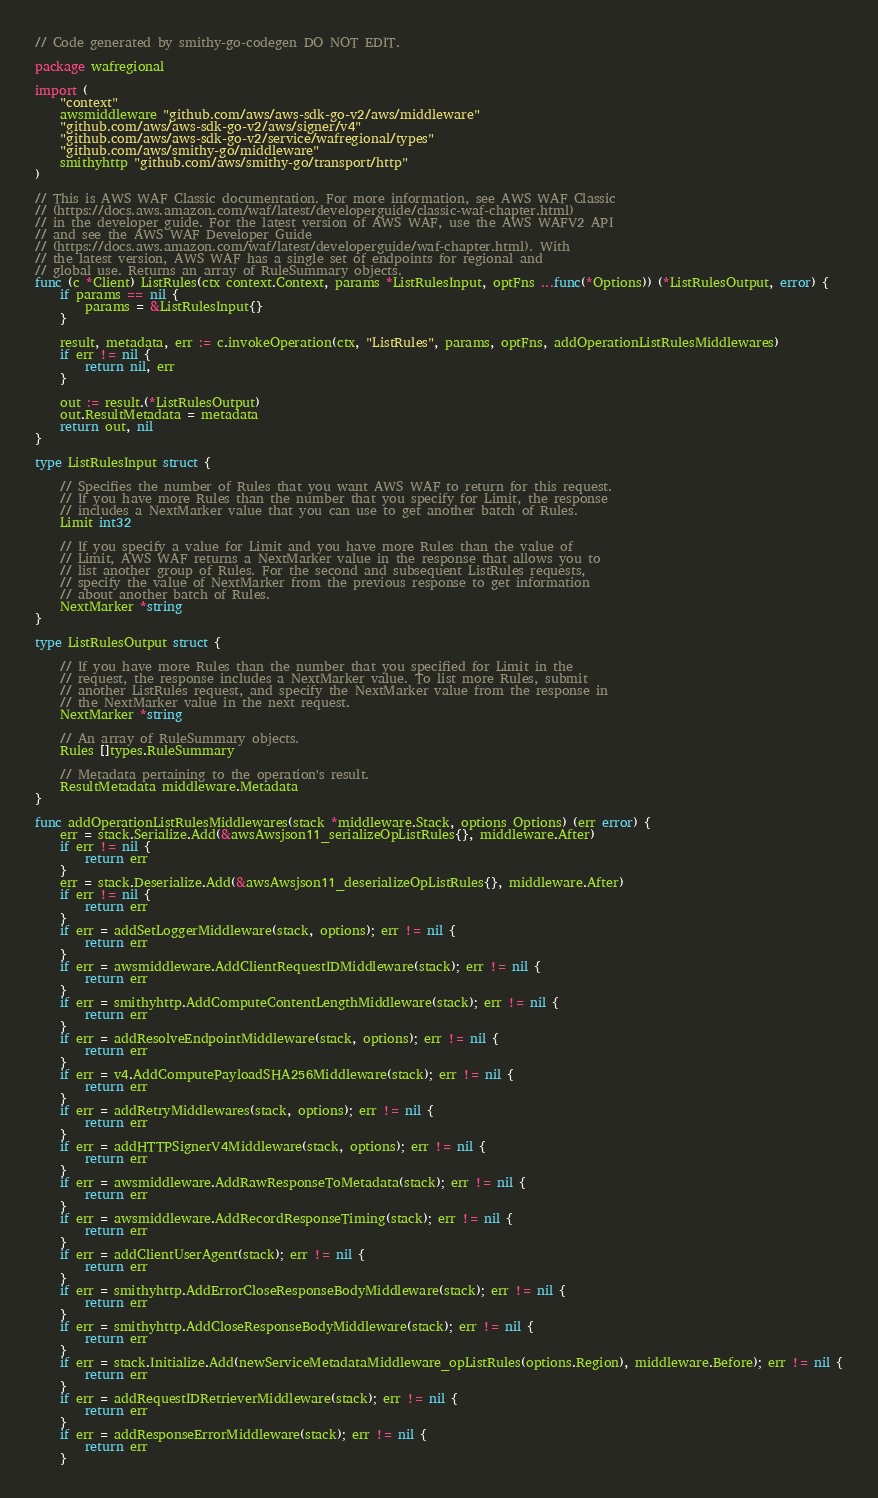<code> <loc_0><loc_0><loc_500><loc_500><_Go_>// Code generated by smithy-go-codegen DO NOT EDIT.

package wafregional

import (
	"context"
	awsmiddleware "github.com/aws/aws-sdk-go-v2/aws/middleware"
	"github.com/aws/aws-sdk-go-v2/aws/signer/v4"
	"github.com/aws/aws-sdk-go-v2/service/wafregional/types"
	"github.com/aws/smithy-go/middleware"
	smithyhttp "github.com/aws/smithy-go/transport/http"
)

// This is AWS WAF Classic documentation. For more information, see AWS WAF Classic
// (https://docs.aws.amazon.com/waf/latest/developerguide/classic-waf-chapter.html)
// in the developer guide. For the latest version of AWS WAF, use the AWS WAFV2 API
// and see the AWS WAF Developer Guide
// (https://docs.aws.amazon.com/waf/latest/developerguide/waf-chapter.html). With
// the latest version, AWS WAF has a single set of endpoints for regional and
// global use. Returns an array of RuleSummary objects.
func (c *Client) ListRules(ctx context.Context, params *ListRulesInput, optFns ...func(*Options)) (*ListRulesOutput, error) {
	if params == nil {
		params = &ListRulesInput{}
	}

	result, metadata, err := c.invokeOperation(ctx, "ListRules", params, optFns, addOperationListRulesMiddlewares)
	if err != nil {
		return nil, err
	}

	out := result.(*ListRulesOutput)
	out.ResultMetadata = metadata
	return out, nil
}

type ListRulesInput struct {

	// Specifies the number of Rules that you want AWS WAF to return for this request.
	// If you have more Rules than the number that you specify for Limit, the response
	// includes a NextMarker value that you can use to get another batch of Rules.
	Limit int32

	// If you specify a value for Limit and you have more Rules than the value of
	// Limit, AWS WAF returns a NextMarker value in the response that allows you to
	// list another group of Rules. For the second and subsequent ListRules requests,
	// specify the value of NextMarker from the previous response to get information
	// about another batch of Rules.
	NextMarker *string
}

type ListRulesOutput struct {

	// If you have more Rules than the number that you specified for Limit in the
	// request, the response includes a NextMarker value. To list more Rules, submit
	// another ListRules request, and specify the NextMarker value from the response in
	// the NextMarker value in the next request.
	NextMarker *string

	// An array of RuleSummary objects.
	Rules []types.RuleSummary

	// Metadata pertaining to the operation's result.
	ResultMetadata middleware.Metadata
}

func addOperationListRulesMiddlewares(stack *middleware.Stack, options Options) (err error) {
	err = stack.Serialize.Add(&awsAwsjson11_serializeOpListRules{}, middleware.After)
	if err != nil {
		return err
	}
	err = stack.Deserialize.Add(&awsAwsjson11_deserializeOpListRules{}, middleware.After)
	if err != nil {
		return err
	}
	if err = addSetLoggerMiddleware(stack, options); err != nil {
		return err
	}
	if err = awsmiddleware.AddClientRequestIDMiddleware(stack); err != nil {
		return err
	}
	if err = smithyhttp.AddComputeContentLengthMiddleware(stack); err != nil {
		return err
	}
	if err = addResolveEndpointMiddleware(stack, options); err != nil {
		return err
	}
	if err = v4.AddComputePayloadSHA256Middleware(stack); err != nil {
		return err
	}
	if err = addRetryMiddlewares(stack, options); err != nil {
		return err
	}
	if err = addHTTPSignerV4Middleware(stack, options); err != nil {
		return err
	}
	if err = awsmiddleware.AddRawResponseToMetadata(stack); err != nil {
		return err
	}
	if err = awsmiddleware.AddRecordResponseTiming(stack); err != nil {
		return err
	}
	if err = addClientUserAgent(stack); err != nil {
		return err
	}
	if err = smithyhttp.AddErrorCloseResponseBodyMiddleware(stack); err != nil {
		return err
	}
	if err = smithyhttp.AddCloseResponseBodyMiddleware(stack); err != nil {
		return err
	}
	if err = stack.Initialize.Add(newServiceMetadataMiddleware_opListRules(options.Region), middleware.Before); err != nil {
		return err
	}
	if err = addRequestIDRetrieverMiddleware(stack); err != nil {
		return err
	}
	if err = addResponseErrorMiddleware(stack); err != nil {
		return err
	}</code> 